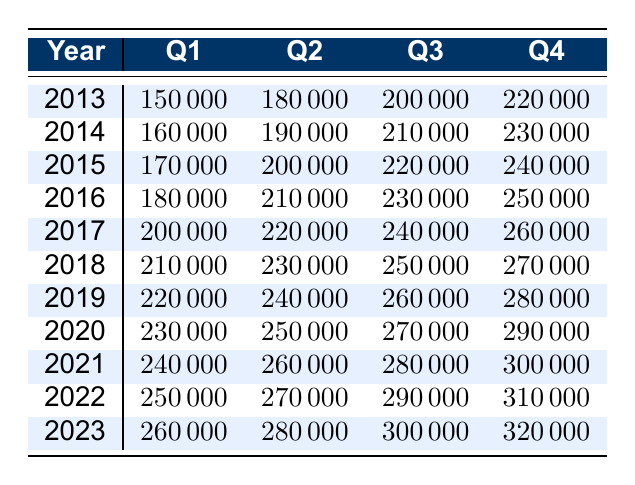What was the revenue in Q3 of 2021? According to the table, the revenue in Q3 of 2021 is listed under the year 2021 and Q3 column, which shows a value of 280000.
Answer: 280000 In which year did Q2 revenue first exceed 250000? Looking at the Q2 revenues, the first time it exceeds 250000 is in the year 2021, where the Q2 revenue is 260000.
Answer: 2021 What is the total revenue for Q4 across all years shown? To find the total Q4 revenue, we need to sum the Q4 values for all years: (220000 + 230000 + 240000 + 250000 + 260000 + 270000 + 280000 + 290000 + 300000 + 310000 + 320000) = 2980000.
Answer: 2980000 Is the revenue for Q1 consistently increasing each year? By checking the Q1 values from 2013 to 2023, we see that each year's Q1 revenue is greater than the previous year's: 150000, 160000, 170000, 180000, 200000, 210000, 220000, 230000, 240000, 250000, 260000. Thus, it is consistent.
Answer: Yes What was the average Q3 revenue over the years? To calculate the average Q3 revenue, we add the Q3 revenues: (200000 + 210000 + 220000 + 230000 + 240000 + 250000 + 260000 + 270000 + 280000 + 290000 + 300000) = 2850000. There are 11 data points, so the average is 2850000 / 11 = 259090.91, which rounds to 259091.
Answer: 259091 Which quarter experienced the highest revenue overall? To find the quarter with the highest revenue, we consider the maximum values for each quarter: Q1 = 260000, Q2 = 280000, Q3 = 300000, and Q4 = 320000. The highest is found in Q4 at 320000 for the year 2023.
Answer: Q4 What is the difference in revenue between Q4 2013 and Q4 2022? The revenue for Q4 2013 is 220000, and for Q4 2022 it is 310000. The difference is 310000 - 220000 = 90000.
Answer: 90000 In how many years did Q1 revenue exceed 200000? Reviewing the Q1 revenue data, we see that Q1 revenue exceeded 200000 in the years 2017, 2018, 2019, 2020, 2021, 2022, and 2023. This totals to 7 years.
Answer: 7 